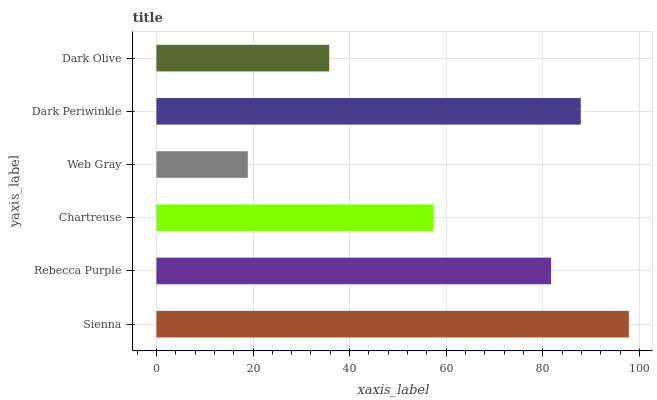Is Web Gray the minimum?
Answer yes or no. Yes. Is Sienna the maximum?
Answer yes or no. Yes. Is Rebecca Purple the minimum?
Answer yes or no. No. Is Rebecca Purple the maximum?
Answer yes or no. No. Is Sienna greater than Rebecca Purple?
Answer yes or no. Yes. Is Rebecca Purple less than Sienna?
Answer yes or no. Yes. Is Rebecca Purple greater than Sienna?
Answer yes or no. No. Is Sienna less than Rebecca Purple?
Answer yes or no. No. Is Rebecca Purple the high median?
Answer yes or no. Yes. Is Chartreuse the low median?
Answer yes or no. Yes. Is Web Gray the high median?
Answer yes or no. No. Is Web Gray the low median?
Answer yes or no. No. 